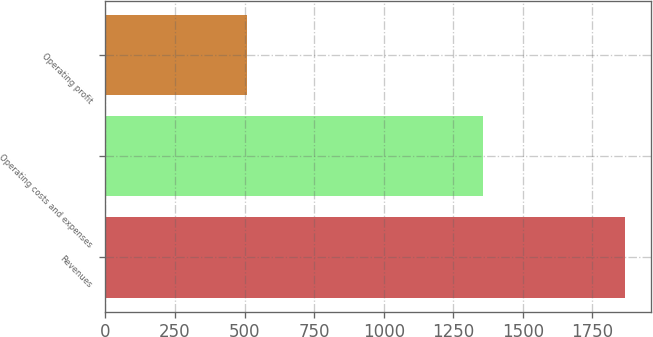Convert chart to OTSL. <chart><loc_0><loc_0><loc_500><loc_500><bar_chart><fcel>Revenues<fcel>Operating costs and expenses<fcel>Operating profit<nl><fcel>1867<fcel>1357<fcel>510<nl></chart> 